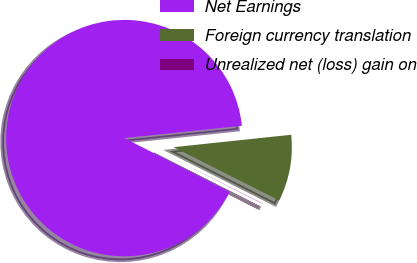Convert chart to OTSL. <chart><loc_0><loc_0><loc_500><loc_500><pie_chart><fcel>Net Earnings<fcel>Foreign currency translation<fcel>Unrealized net (loss) gain on<nl><fcel>90.83%<fcel>9.12%<fcel>0.04%<nl></chart> 